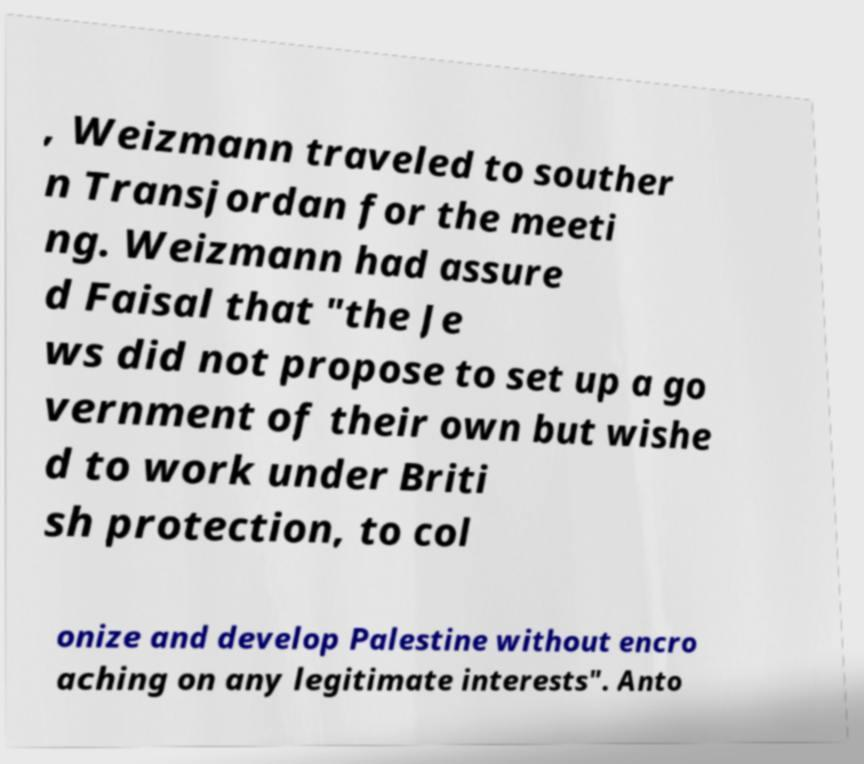Could you extract and type out the text from this image? , Weizmann traveled to souther n Transjordan for the meeti ng. Weizmann had assure d Faisal that "the Je ws did not propose to set up a go vernment of their own but wishe d to work under Briti sh protection, to col onize and develop Palestine without encro aching on any legitimate interests". Anto 